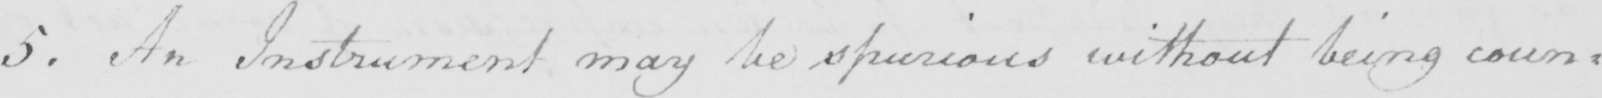Can you read and transcribe this handwriting? 5 . An Instrument may be spurious without being coun= 